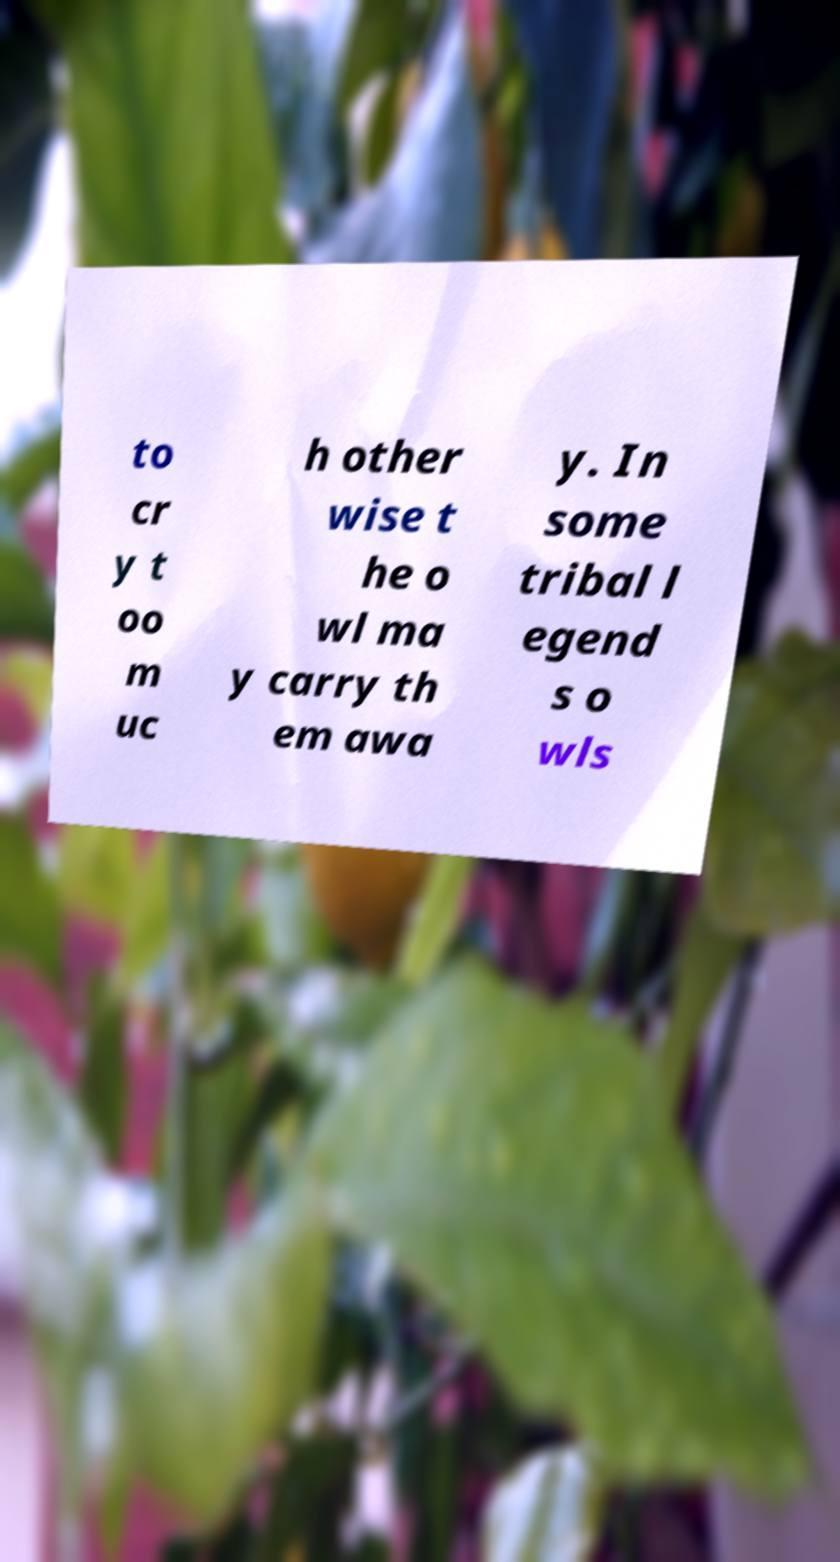Please read and relay the text visible in this image. What does it say? to cr y t oo m uc h other wise t he o wl ma y carry th em awa y. In some tribal l egend s o wls 